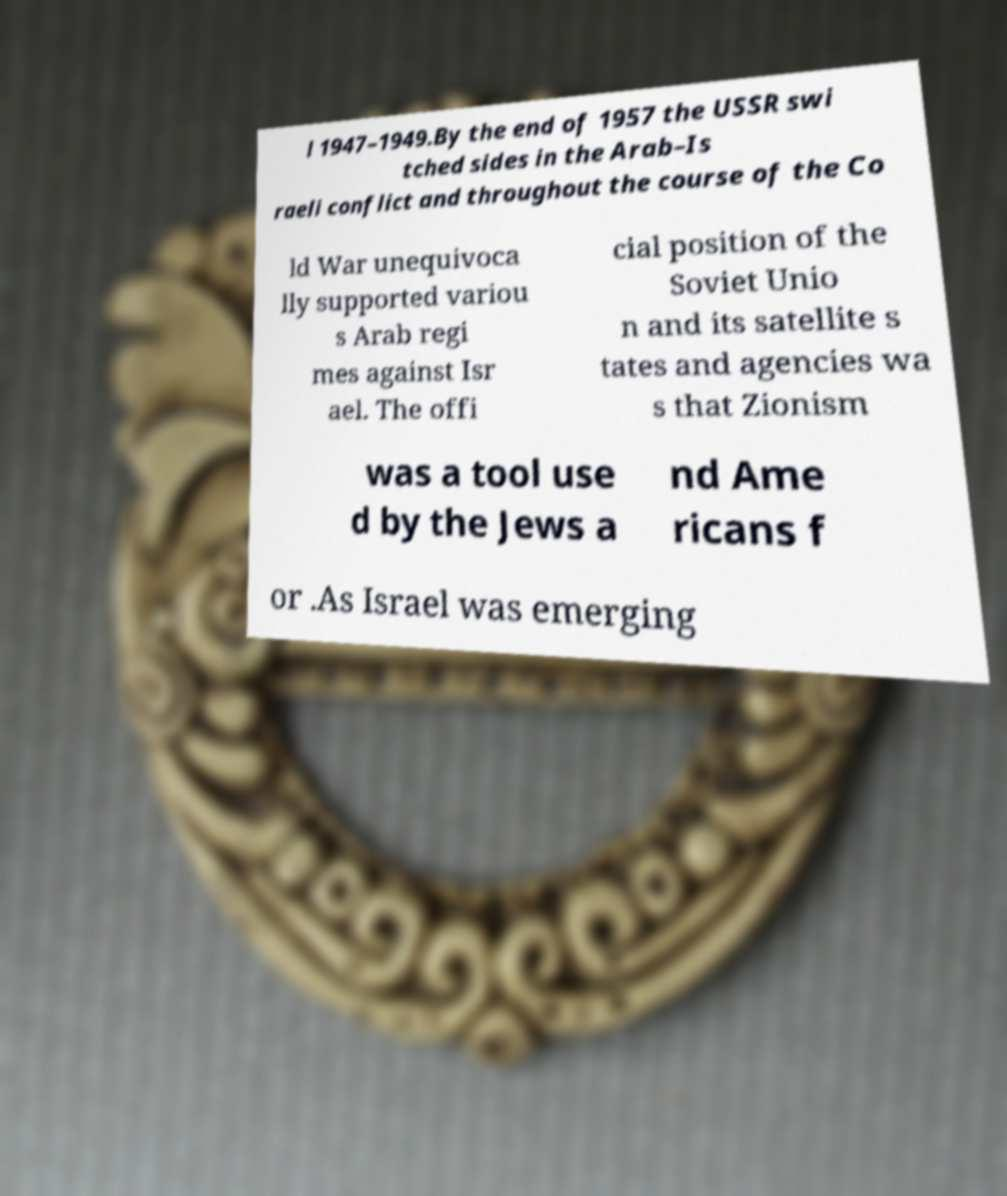Could you assist in decoding the text presented in this image and type it out clearly? l 1947–1949.By the end of 1957 the USSR swi tched sides in the Arab–Is raeli conflict and throughout the course of the Co ld War unequivoca lly supported variou s Arab regi mes against Isr ael. The offi cial position of the Soviet Unio n and its satellite s tates and agencies wa s that Zionism was a tool use d by the Jews a nd Ame ricans f or .As Israel was emerging 